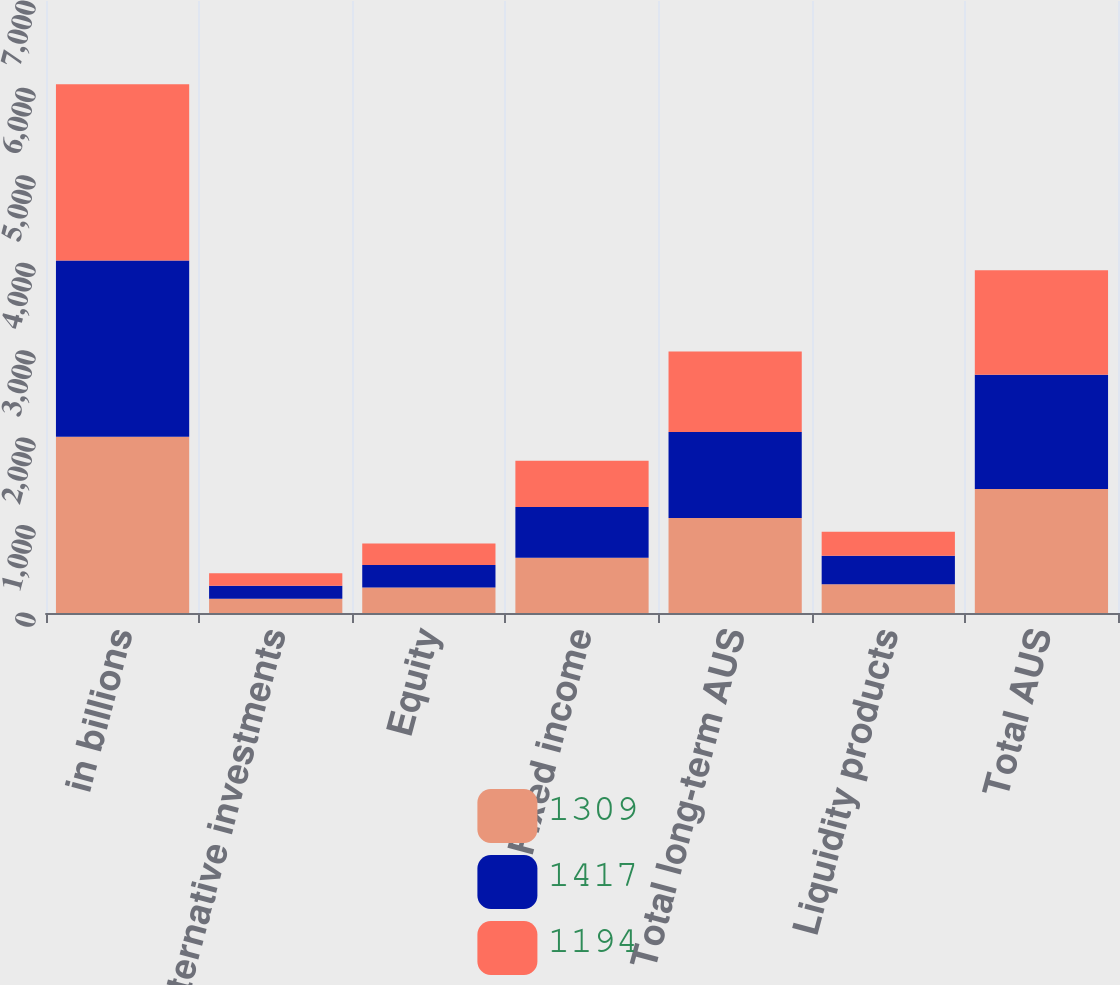<chart> <loc_0><loc_0><loc_500><loc_500><stacked_bar_chart><ecel><fcel>in billions<fcel>Alternative investments<fcel>Equity<fcel>Fixed income<fcel>Total long-term AUS<fcel>Liquidity products<fcel>Total AUS<nl><fcel>1309<fcel>2017<fcel>162<fcel>292<fcel>633<fcel>1087<fcel>330<fcel>1417<nl><fcel>1417<fcel>2016<fcel>149<fcel>256<fcel>578<fcel>983<fcel>326<fcel>1309<nl><fcel>1194<fcel>2015<fcel>145<fcel>247<fcel>530<fcel>922<fcel>272<fcel>1194<nl></chart> 